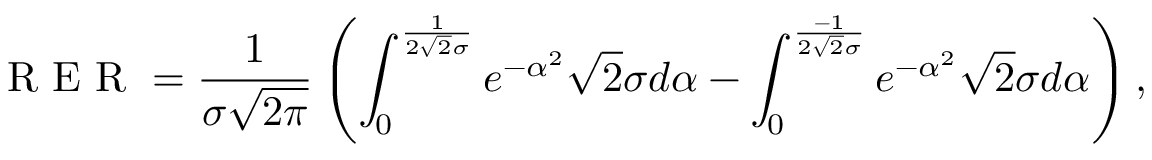Convert formula to latex. <formula><loc_0><loc_0><loc_500><loc_500>R E R = \frac { 1 } { \sigma \sqrt { 2 \pi } } \left ( \int _ { 0 } ^ { \frac { 1 } { 2 \sqrt { 2 } \sigma } } e ^ { - \alpha ^ { 2 } } \sqrt { 2 } \sigma d \alpha - \int _ { 0 } ^ { \frac { - 1 } { 2 \sqrt { 2 } \sigma } } e ^ { - \alpha ^ { 2 } } \sqrt { 2 } \sigma d \alpha \right ) ,</formula> 